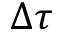<formula> <loc_0><loc_0><loc_500><loc_500>\Delta \tau</formula> 